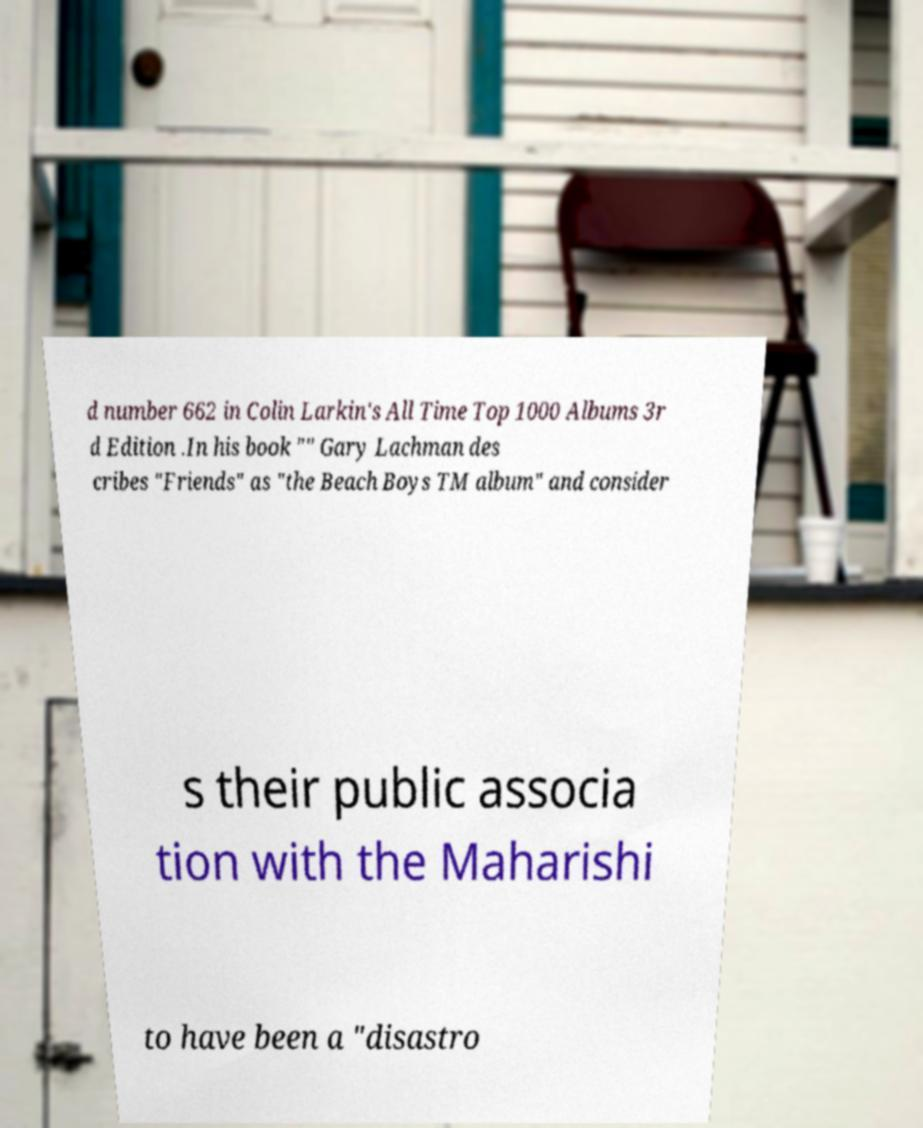I need the written content from this picture converted into text. Can you do that? d number 662 in Colin Larkin's All Time Top 1000 Albums 3r d Edition .In his book "" Gary Lachman des cribes "Friends" as "the Beach Boys TM album" and consider s their public associa tion with the Maharishi to have been a "disastro 